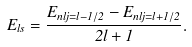Convert formula to latex. <formula><loc_0><loc_0><loc_500><loc_500>E _ { l s } = \frac { E _ { n l j = l - 1 / 2 } - E _ { n l j = l + 1 / 2 } } { 2 l + 1 } .</formula> 